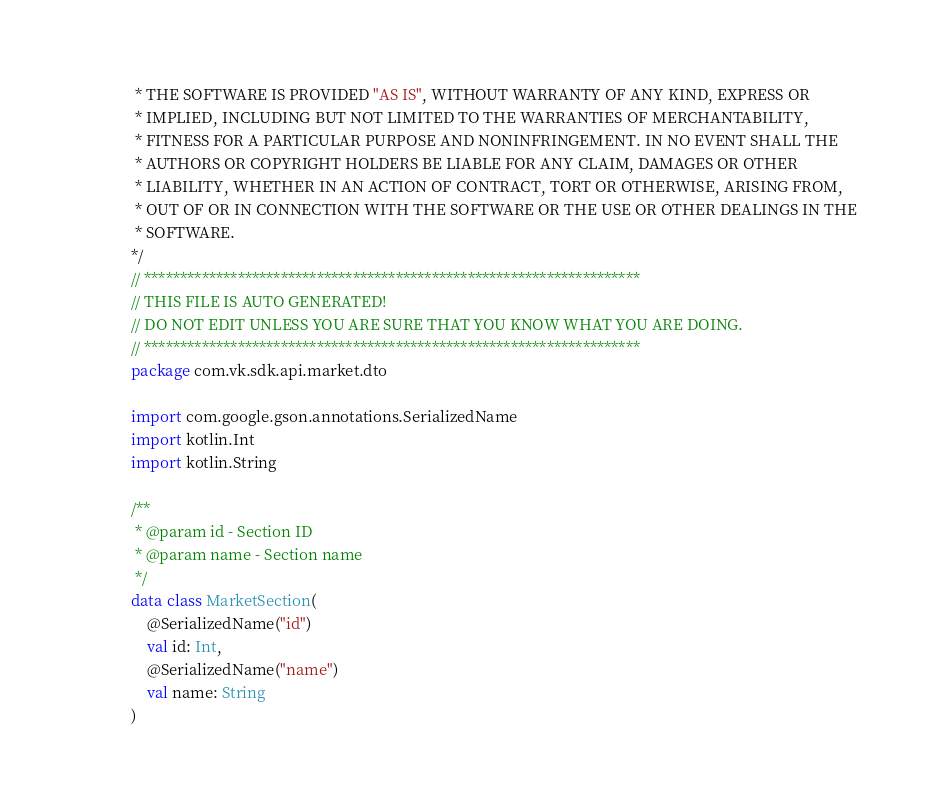Convert code to text. <code><loc_0><loc_0><loc_500><loc_500><_Kotlin_> * THE SOFTWARE IS PROVIDED "AS IS", WITHOUT WARRANTY OF ANY KIND, EXPRESS OR
 * IMPLIED, INCLUDING BUT NOT LIMITED TO THE WARRANTIES OF MERCHANTABILITY,
 * FITNESS FOR A PARTICULAR PURPOSE AND NONINFRINGEMENT. IN NO EVENT SHALL THE
 * AUTHORS OR COPYRIGHT HOLDERS BE LIABLE FOR ANY CLAIM, DAMAGES OR OTHER
 * LIABILITY, WHETHER IN AN ACTION OF CONTRACT, TORT OR OTHERWISE, ARISING FROM,
 * OUT OF OR IN CONNECTION WITH THE SOFTWARE OR THE USE OR OTHER DEALINGS IN THE
 * SOFTWARE.
*/
// *********************************************************************
// THIS FILE IS AUTO GENERATED!
// DO NOT EDIT UNLESS YOU ARE SURE THAT YOU KNOW WHAT YOU ARE DOING.
// *********************************************************************
package com.vk.sdk.api.market.dto

import com.google.gson.annotations.SerializedName
import kotlin.Int
import kotlin.String

/**
 * @param id - Section ID
 * @param name - Section name
 */
data class MarketSection(
    @SerializedName("id")
    val id: Int,
    @SerializedName("name")
    val name: String
)
</code> 